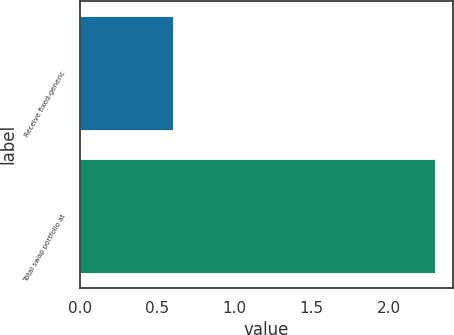<chart> <loc_0><loc_0><loc_500><loc_500><bar_chart><fcel>Receive fixed-generic<fcel>Total swap portfolio at<nl><fcel>0.6<fcel>2.3<nl></chart> 